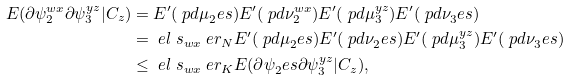Convert formula to latex. <formula><loc_0><loc_0><loc_500><loc_500>E ( \partial \psi _ { 2 } ^ { w x } \partial \psi _ { 3 } ^ { y z } | C _ { z } ) & = E ^ { \prime } ( \ p d \mu _ { 2 } ^ { \ } e s ) E ^ { \prime } ( \ p d \nu _ { 2 } ^ { w x } ) E ^ { \prime } ( \ p d \mu _ { 3 } ^ { y z } ) E ^ { \prime } ( \ p d \nu _ { 3 } ^ { \ } e s ) \\ & = \ e l \ s _ { w x } \ e r _ { N } E ^ { \prime } ( \ p d \mu _ { 2 } ^ { \ } e s ) E ^ { \prime } ( \ p d \nu _ { 2 } ^ { \ } e s ) E ^ { \prime } ( \ p d \mu _ { 3 } ^ { y z } ) E ^ { \prime } ( \ p d \nu _ { 3 } ^ { \ } e s ) \\ & \leq \ e l \ s _ { w x } \ e r _ { K } E ( \partial \psi _ { 2 } ^ { \ } e s \partial \psi _ { 3 } ^ { y z } | C _ { z } ) ,</formula> 